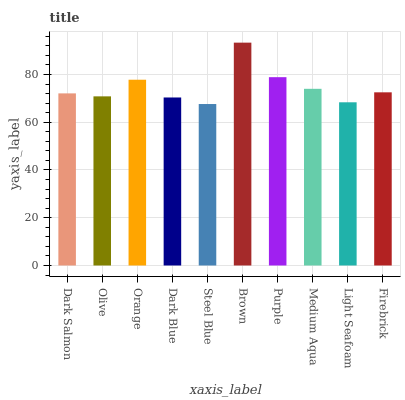Is Steel Blue the minimum?
Answer yes or no. Yes. Is Brown the maximum?
Answer yes or no. Yes. Is Olive the minimum?
Answer yes or no. No. Is Olive the maximum?
Answer yes or no. No. Is Dark Salmon greater than Olive?
Answer yes or no. Yes. Is Olive less than Dark Salmon?
Answer yes or no. Yes. Is Olive greater than Dark Salmon?
Answer yes or no. No. Is Dark Salmon less than Olive?
Answer yes or no. No. Is Firebrick the high median?
Answer yes or no. Yes. Is Dark Salmon the low median?
Answer yes or no. Yes. Is Purple the high median?
Answer yes or no. No. Is Olive the low median?
Answer yes or no. No. 